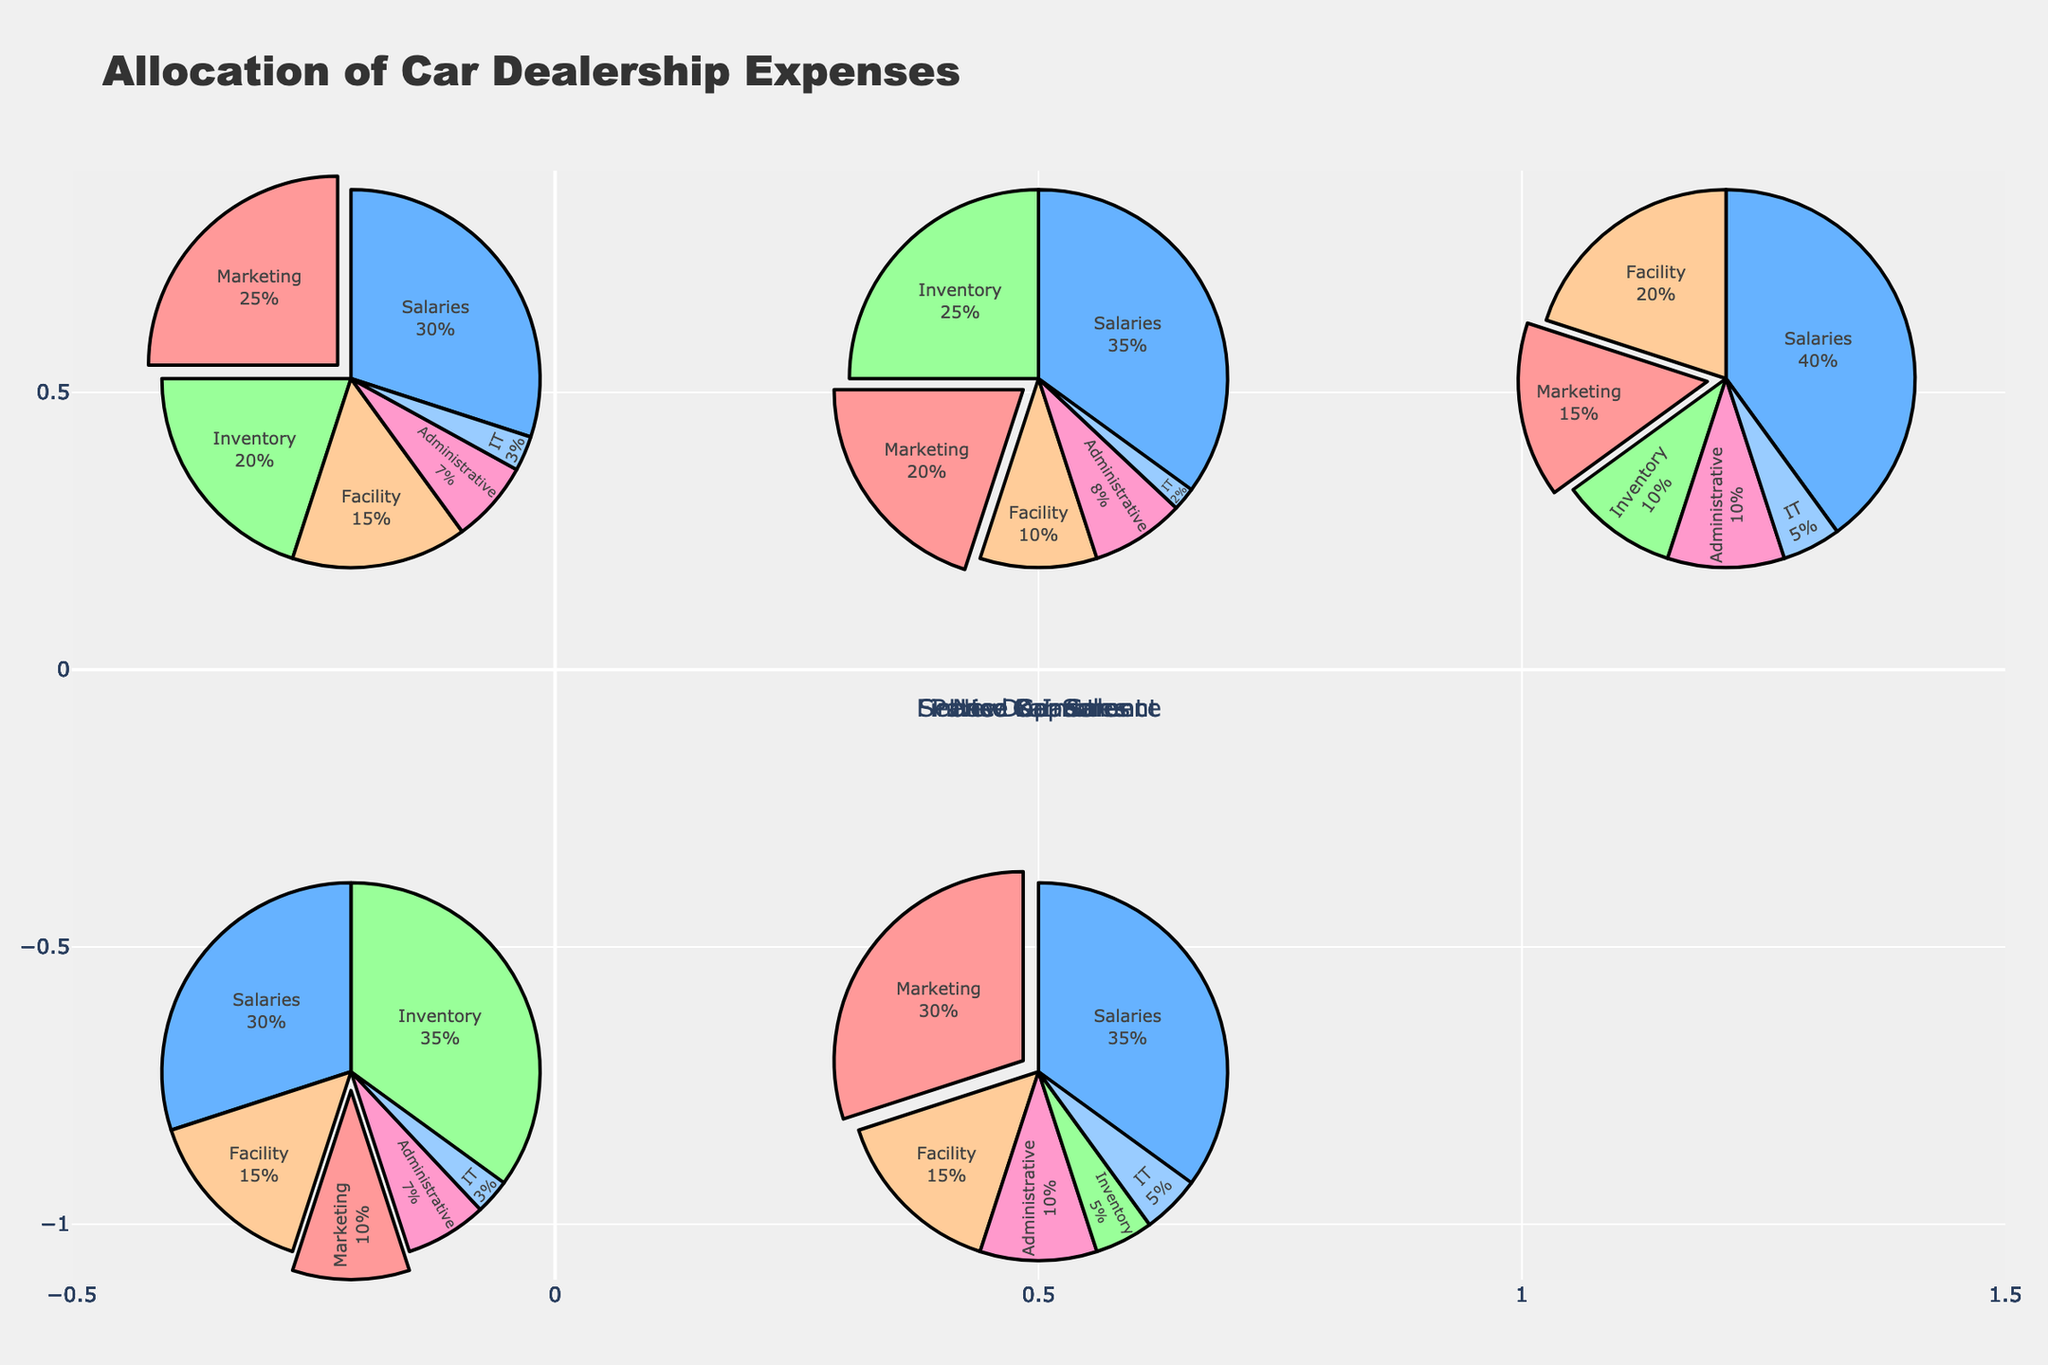what is the percentage of expenses allocated to marketing in the New Car Sales category? In the New Car Sales pie chart, look at the slice labeled "Marketing" to find its percentage share.
Answer: 25% Which category allocates the highest percentage to salaries? Compare the "Salaries" percentage across all pie charts. The Service Department allocates 40%, the highest among all categories.
Answer: Service Department How do the percentages for administrative expenses in Used Car Sales and Finance & Insurance compare? The Used Car Sales pie chart shows 8% for administrative expenses, and the Finance & Insurance pie chart shows 10%.
Answer: Finance & Insurance has a higher percentage How much more is spent on inventory in the Parts Department compared to the Service Department? Inventory allocation in the Parts Department is 35%, while in the Service Department it is 10%. The difference is 35% - 10% = 25%.
Answer: 25% What is the combined percentage of expenses allocated to IT across all categories? Sum the IT expense percentages for all the categories: 3% (New Car Sales) + 2% (Used Car Sales) + 5% (Service Department) + 3% (Parts Department) + 5% (Finance & Insurance) = 18%.
Answer: 18% Which category spends the least on facility expenses? Compare the facility expense percentages across all categories. Used Car Sales spends 10%, the lowest among the categories.
Answer: Used Car Sales What fraction of the Parts Department’s expenses is allocated to administrative tasks? The Parts Department allocates 7% to administrative tasks, visualized as one of the pie slices.
Answer: 7% What is the difference between the marketing expense percentages in New Car Sales and Finance & Insurance? The New Car Sales pie chart shows 25% for marketing, and the Finance & Insurance pie chart shows 30%. The difference is 30% - 25% = 5%.
Answer: 5% Which category has the largest slice for facility expenses? Compare the facility expense percentages. The Service Department has the highest with 20%.
Answer: Service Department 